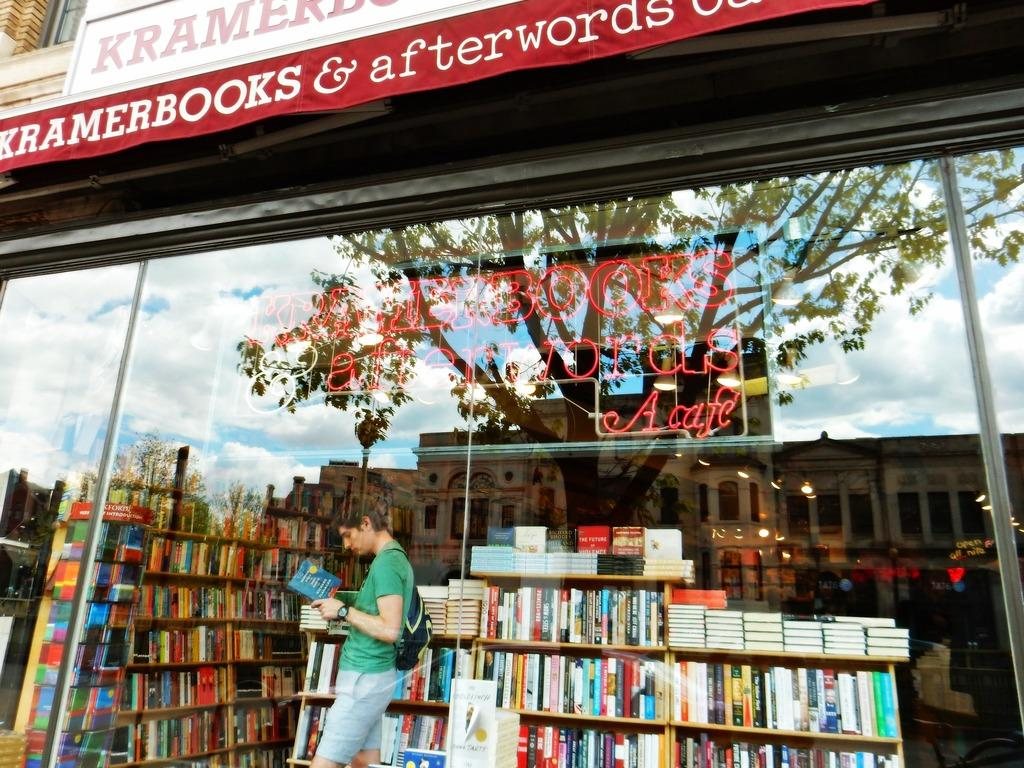<image>
Provide a brief description of the given image. the word afterwords is above the library with many books 